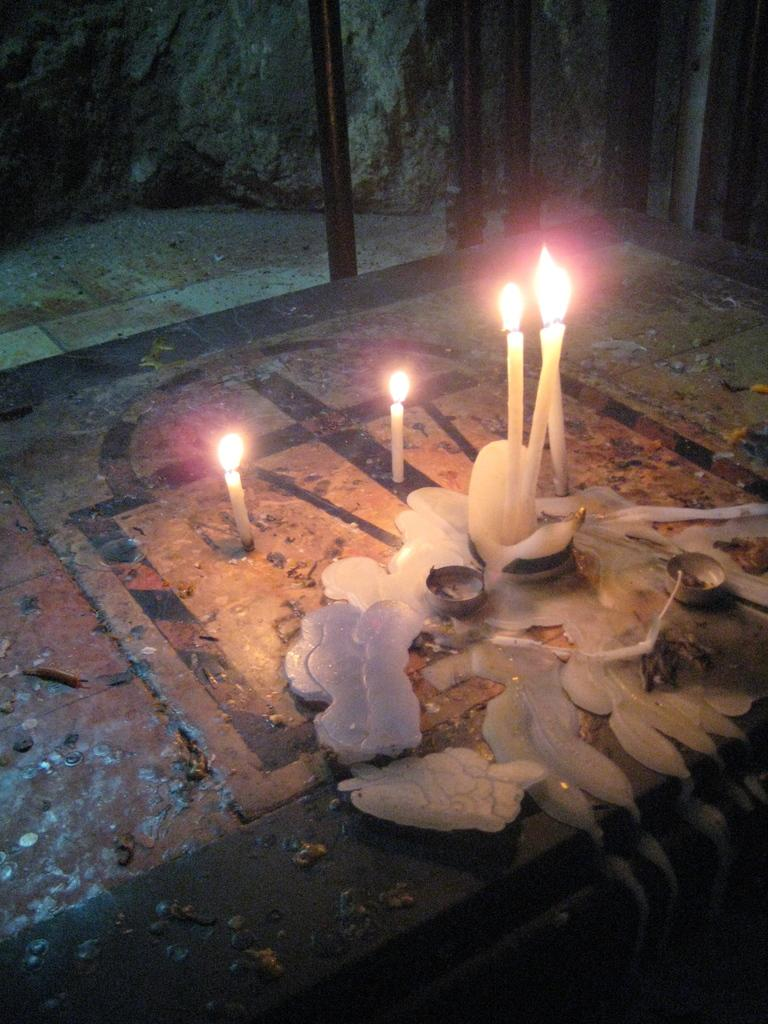What objects are placed on the floor in the image? There are candles on the floor in the image. What can be seen in the background of the image? There are iron rods in the background of the image. What type of sheet is covering the candles in the image? There is no sheet covering the candles in the image; they are directly on the floor. 